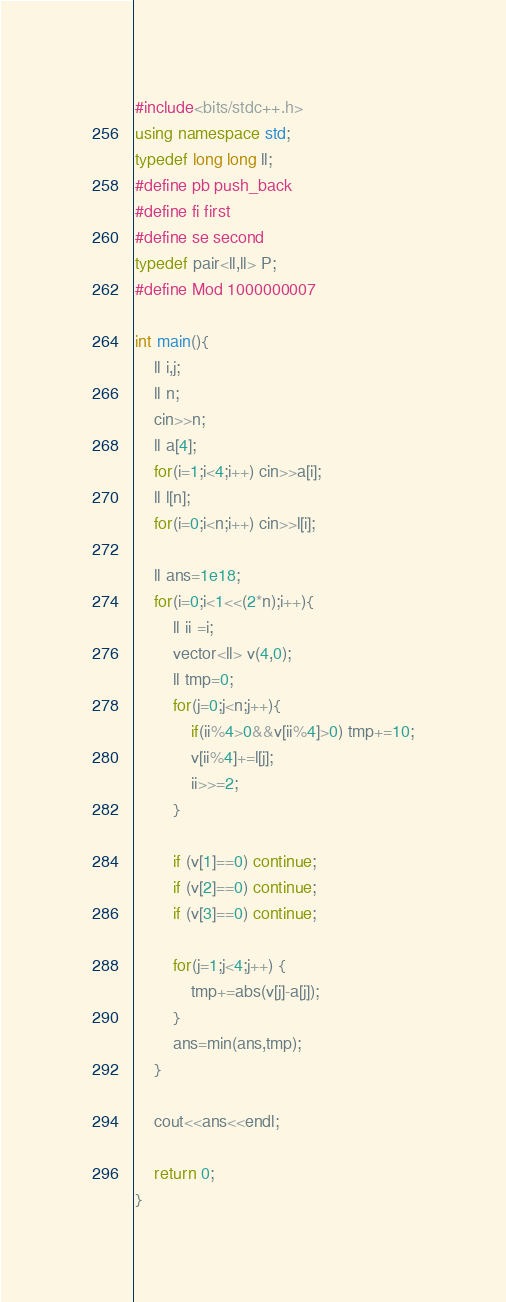Convert code to text. <code><loc_0><loc_0><loc_500><loc_500><_C++_>#include<bits/stdc++.h>
using namespace std;
typedef long long ll;
#define pb push_back
#define fi first
#define se second
typedef pair<ll,ll> P;
#define Mod 1000000007

int main(){
    ll i,j;
    ll n;
    cin>>n;
    ll a[4];
    for(i=1;i<4;i++) cin>>a[i];
    ll l[n];
    for(i=0;i<n;i++) cin>>l[i];

    ll ans=1e18;
    for(i=0;i<1<<(2*n);i++){
        ll ii =i;
        vector<ll> v(4,0);
        ll tmp=0;
        for(j=0;j<n;j++){
            if(ii%4>0&&v[ii%4]>0) tmp+=10;
            v[ii%4]+=l[j];
            ii>>=2;
        }

        if (v[1]==0) continue;
        if (v[2]==0) continue;
        if (v[3]==0) continue;

        for(j=1;j<4;j++) {
            tmp+=abs(v[j]-a[j]);
        }
        ans=min(ans,tmp);
    }

    cout<<ans<<endl;

    return 0;
}</code> 